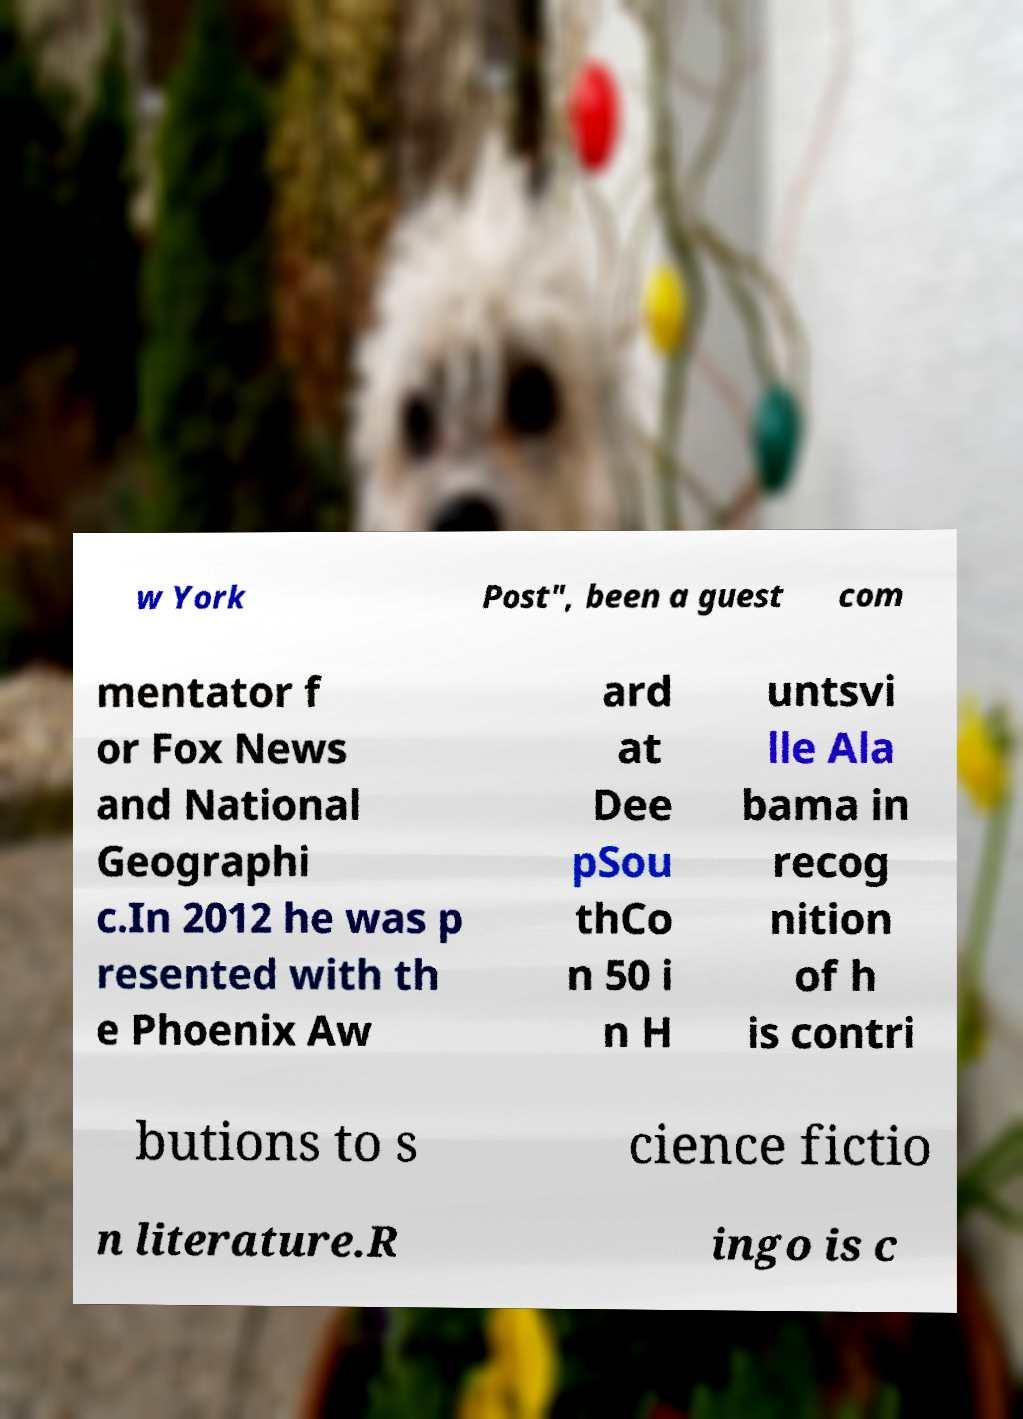What messages or text are displayed in this image? I need them in a readable, typed format. w York Post", been a guest com mentator f or Fox News and National Geographi c.In 2012 he was p resented with th e Phoenix Aw ard at Dee pSou thCo n 50 i n H untsvi lle Ala bama in recog nition of h is contri butions to s cience fictio n literature.R ingo is c 